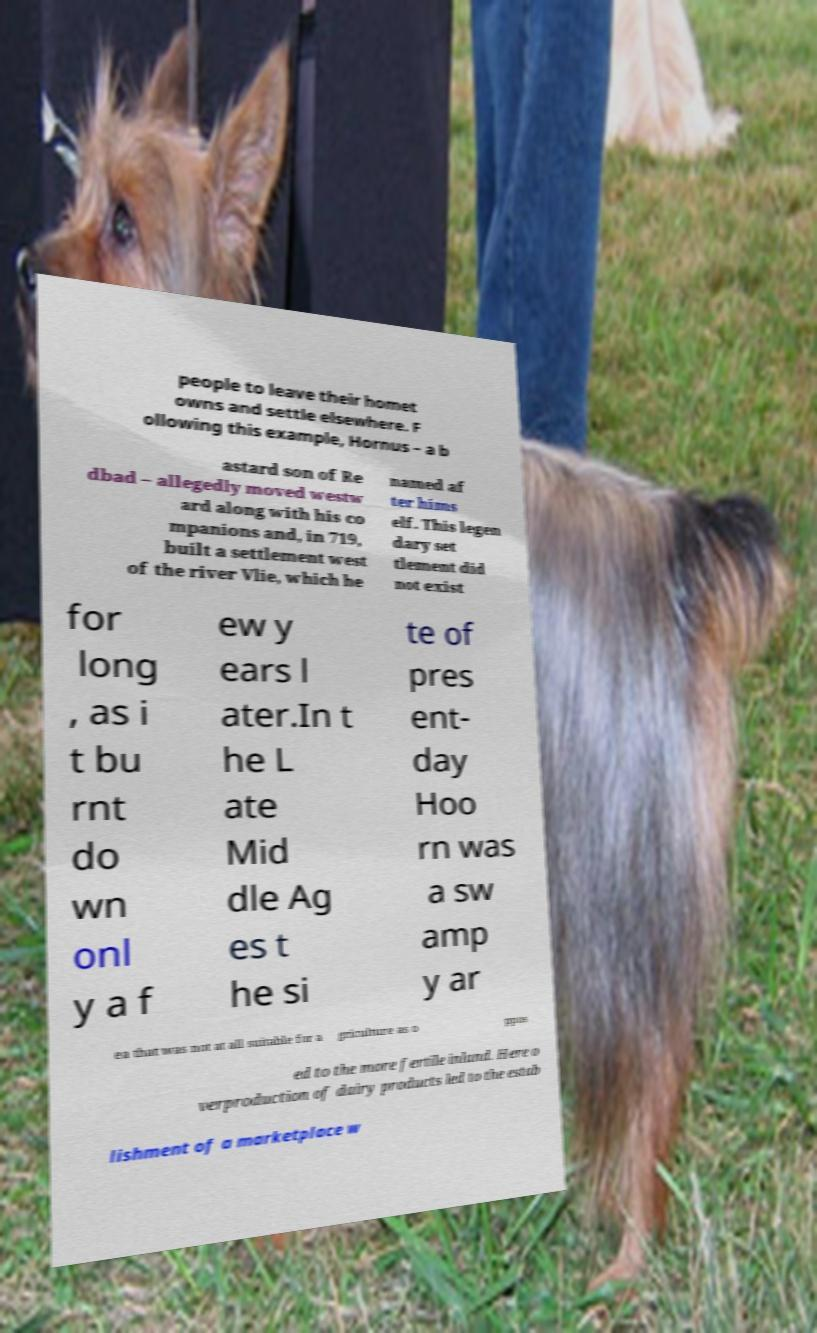There's text embedded in this image that I need extracted. Can you transcribe it verbatim? people to leave their homet owns and settle elsewhere. F ollowing this example, Hornus – a b astard son of Re dbad – allegedly moved westw ard along with his co mpanions and, in 719, built a settlement west of the river Vlie, which he named af ter hims elf. This legen dary set tlement did not exist for long , as i t bu rnt do wn onl y a f ew y ears l ater.In t he L ate Mid dle Ag es t he si te of pres ent- day Hoo rn was a sw amp y ar ea that was not at all suitable for a griculture as o ppos ed to the more fertile inland. Here o verproduction of dairy products led to the estab lishment of a marketplace w 